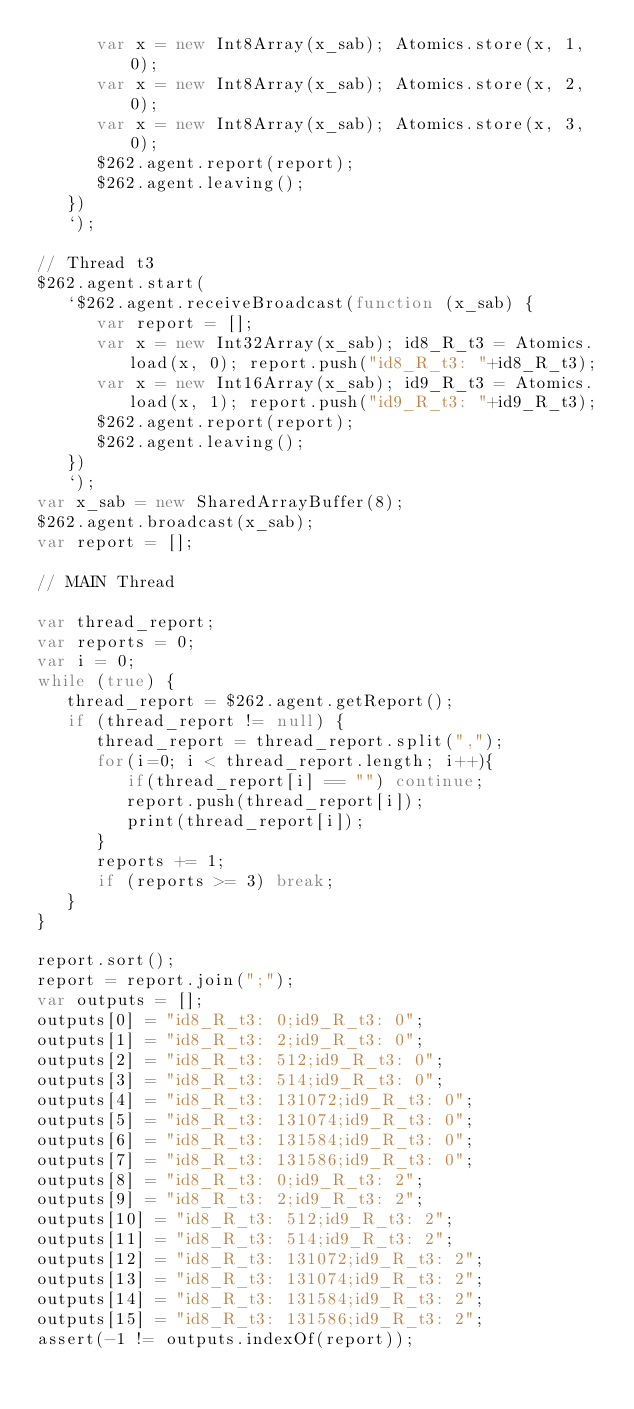<code> <loc_0><loc_0><loc_500><loc_500><_JavaScript_>      var x = new Int8Array(x_sab); Atomics.store(x, 1, 0);
      var x = new Int8Array(x_sab); Atomics.store(x, 2, 0);
      var x = new Int8Array(x_sab); Atomics.store(x, 3, 0);
      $262.agent.report(report);
      $262.agent.leaving();
   })
   `);

// Thread t3
$262.agent.start(
   `$262.agent.receiveBroadcast(function (x_sab) {
      var report = [];
      var x = new Int32Array(x_sab); id8_R_t3 = Atomics.load(x, 0); report.push("id8_R_t3: "+id8_R_t3);
      var x = new Int16Array(x_sab); id9_R_t3 = Atomics.load(x, 1); report.push("id9_R_t3: "+id9_R_t3);
      $262.agent.report(report);
      $262.agent.leaving();
   })
   `);
var x_sab = new SharedArrayBuffer(8);
$262.agent.broadcast(x_sab);
var report = [];

// MAIN Thread

var thread_report;
var reports = 0;
var i = 0;
while (true) {
   thread_report = $262.agent.getReport();
   if (thread_report != null) {
      thread_report = thread_report.split(",");
      for(i=0; i < thread_report.length; i++){
         if(thread_report[i] == "") continue;
         report.push(thread_report[i]);
         print(thread_report[i]);
      }
      reports += 1;
      if (reports >= 3) break;
   }
}

report.sort();
report = report.join(";");
var outputs = [];
outputs[0] = "id8_R_t3: 0;id9_R_t3: 0";
outputs[1] = "id8_R_t3: 2;id9_R_t3: 0";
outputs[2] = "id8_R_t3: 512;id9_R_t3: 0";
outputs[3] = "id8_R_t3: 514;id9_R_t3: 0";
outputs[4] = "id8_R_t3: 131072;id9_R_t3: 0";
outputs[5] = "id8_R_t3: 131074;id9_R_t3: 0";
outputs[6] = "id8_R_t3: 131584;id9_R_t3: 0";
outputs[7] = "id8_R_t3: 131586;id9_R_t3: 0";
outputs[8] = "id8_R_t3: 0;id9_R_t3: 2";
outputs[9] = "id8_R_t3: 2;id9_R_t3: 2";
outputs[10] = "id8_R_t3: 512;id9_R_t3: 2";
outputs[11] = "id8_R_t3: 514;id9_R_t3: 2";
outputs[12] = "id8_R_t3: 131072;id9_R_t3: 2";
outputs[13] = "id8_R_t3: 131074;id9_R_t3: 2";
outputs[14] = "id8_R_t3: 131584;id9_R_t3: 2";
outputs[15] = "id8_R_t3: 131586;id9_R_t3: 2";
assert(-1 != outputs.indexOf(report));
</code> 